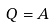<formula> <loc_0><loc_0><loc_500><loc_500>Q = A</formula> 